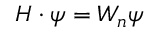Convert formula to latex. <formula><loc_0><loc_0><loc_500><loc_500>H \cdot \psi = W _ { n } \psi</formula> 